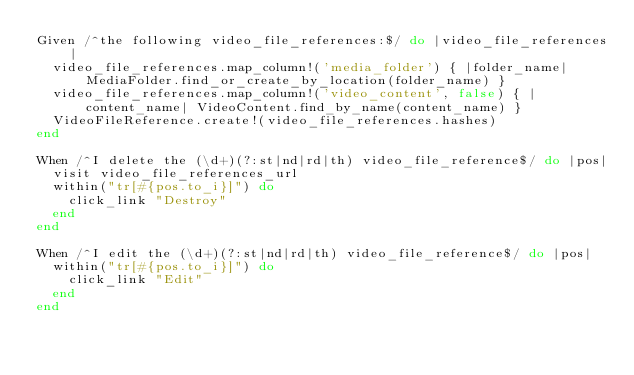Convert code to text. <code><loc_0><loc_0><loc_500><loc_500><_Ruby_>Given /^the following video_file_references:$/ do |video_file_references|
  video_file_references.map_column!('media_folder') { |folder_name| MediaFolder.find_or_create_by_location(folder_name) }
  video_file_references.map_column!('video_content', false) { |content_name| VideoContent.find_by_name(content_name) }
  VideoFileReference.create!(video_file_references.hashes)
end

When /^I delete the (\d+)(?:st|nd|rd|th) video_file_reference$/ do |pos|
  visit video_file_references_url
  within("tr[#{pos.to_i}]") do
    click_link "Destroy"
  end
end

When /^I edit the (\d+)(?:st|nd|rd|th) video_file_reference$/ do |pos|
  within("tr[#{pos.to_i}]") do
    click_link "Edit"
  end
end
</code> 